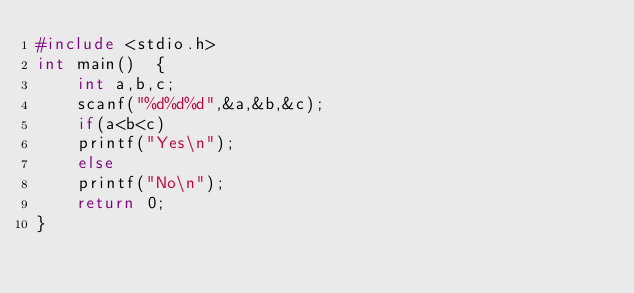<code> <loc_0><loc_0><loc_500><loc_500><_C_>#include <stdio.h>
int main()  {
    int a,b,c;
    scanf("%d%d%d",&a,&b,&c);
    if(a<b<c)
    printf("Yes\n");
    else
    printf("No\n");
    return 0;
}</code> 